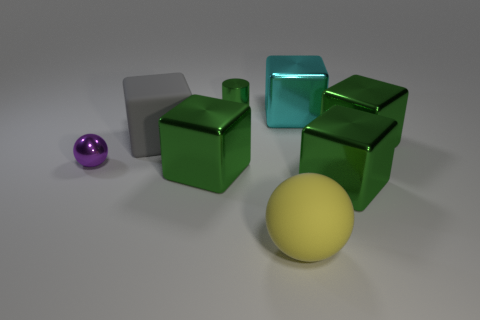How many green cubes must be subtracted to get 1 green cubes? 2 Subtract all brown balls. How many green cubes are left? 3 Add 2 large yellow spheres. How many objects exist? 10 Subtract all cylinders. How many objects are left? 7 Subtract all cyan shiny things. Subtract all tiny brown things. How many objects are left? 7 Add 4 large green cubes. How many large green cubes are left? 7 Add 8 small green rubber balls. How many small green rubber balls exist? 8 Subtract 0 red balls. How many objects are left? 8 